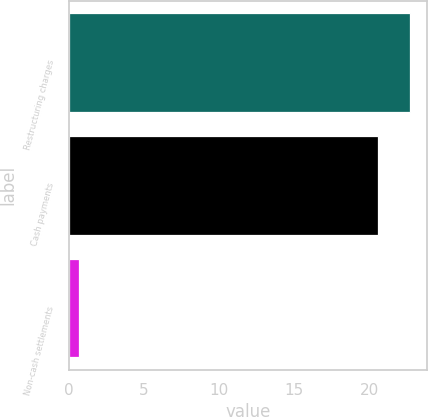Convert chart. <chart><loc_0><loc_0><loc_500><loc_500><bar_chart><fcel>Restructuring charges<fcel>Cash payments<fcel>Non-cash settlements<nl><fcel>22.73<fcel>20.6<fcel>0.7<nl></chart> 